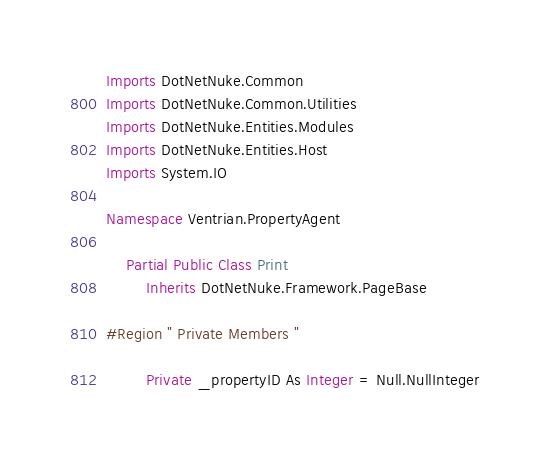<code> <loc_0><loc_0><loc_500><loc_500><_VisualBasic_>Imports DotNetNuke.Common
Imports DotNetNuke.Common.Utilities
Imports DotNetNuke.Entities.Modules
Imports DotNetNuke.Entities.Host
Imports System.IO

Namespace Ventrian.PropertyAgent

    Partial Public Class Print
        Inherits DotNetNuke.Framework.PageBase

#Region " Private Members "

        Private _propertyID As Integer = Null.NullInteger</code> 